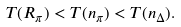<formula> <loc_0><loc_0><loc_500><loc_500>T ( R _ { \pi } ) < T ( n _ { \pi } ) < T ( n _ { \Delta } ) .</formula> 